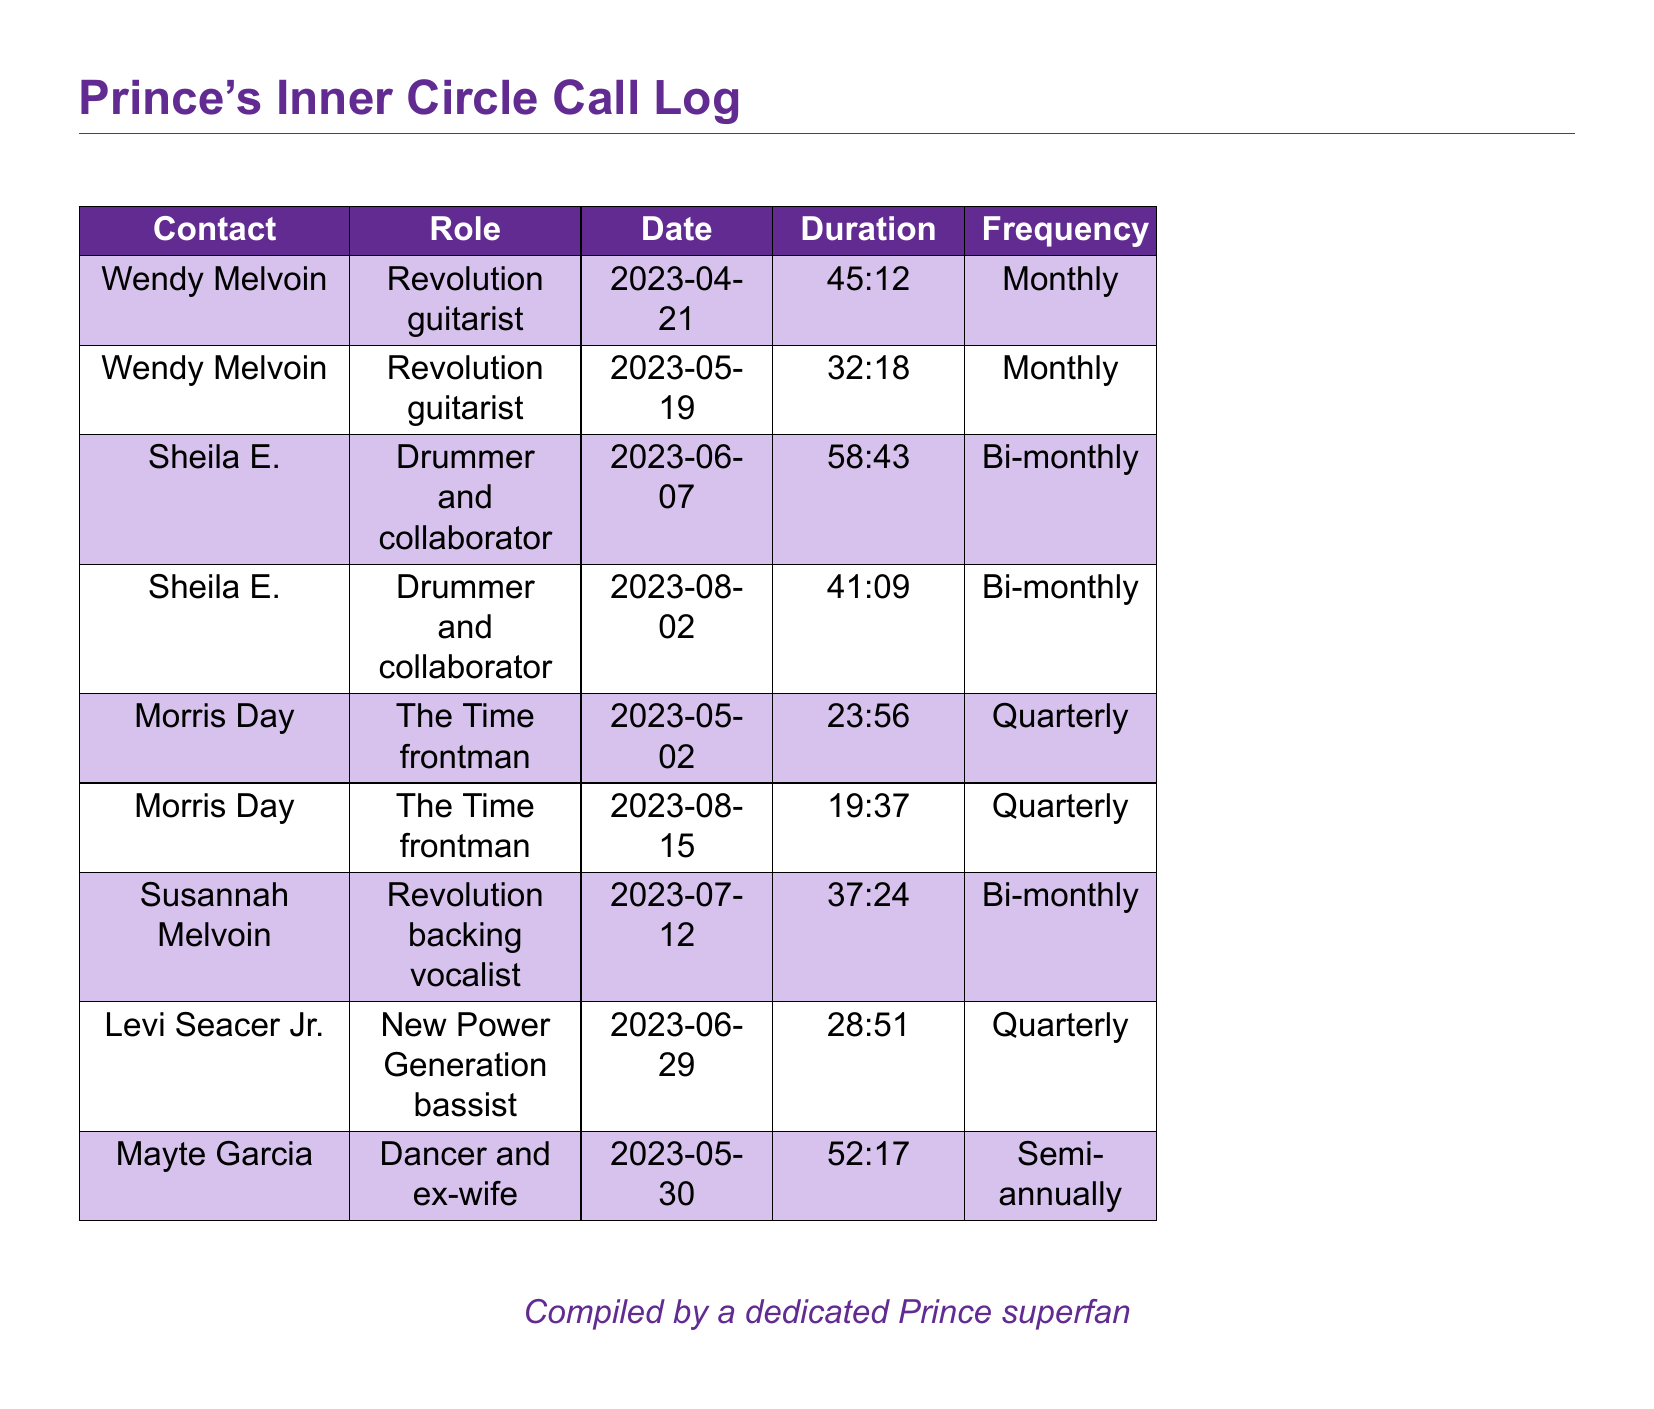What is the duration of the call with Sheila E. on August 2, 2023? The duration of the call with Sheila E. is listed in the document.
Answer: 41:09 How often does Wendy Melvoin have calls? The frequency of Wendy Melvoin's calls is provided in the table.
Answer: Monthly Who is listed as a bassist in the document? The document specifies the roles of the contacts, including Levi Seacer Jr.'s role.
Answer: New Power Generation bassist What was the total number of calls documented for Morris Day? The number of calls for each contact provides insight into their communication frequency.
Answer: 2 Which band is associated with Susannah Melvoin? The role of Susannah Melvoin and her associated band are mentioned in the call log.
Answer: Revolution What is the longest call duration recorded? By comparing the durations of each call in the log, we identify the longest one.
Answer: 58:43 When was the last call made to Mayte Garcia? The date of the last call to Mayte Garcia can be found in the table.
Answer: 2023-05-30 How many contacts have a frequency of bi-monthly calls? A count of contacts with bi-monthly call frequency provides insight into communication habits.
Answer: 2 Which former collaborator had the shortest call duration? By reviewing all the durations, we determine the shortest call.
Answer: 19:37 